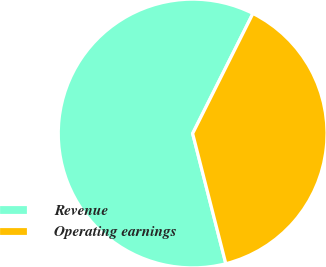Convert chart. <chart><loc_0><loc_0><loc_500><loc_500><pie_chart><fcel>Revenue<fcel>Operating earnings<nl><fcel>61.38%<fcel>38.62%<nl></chart> 